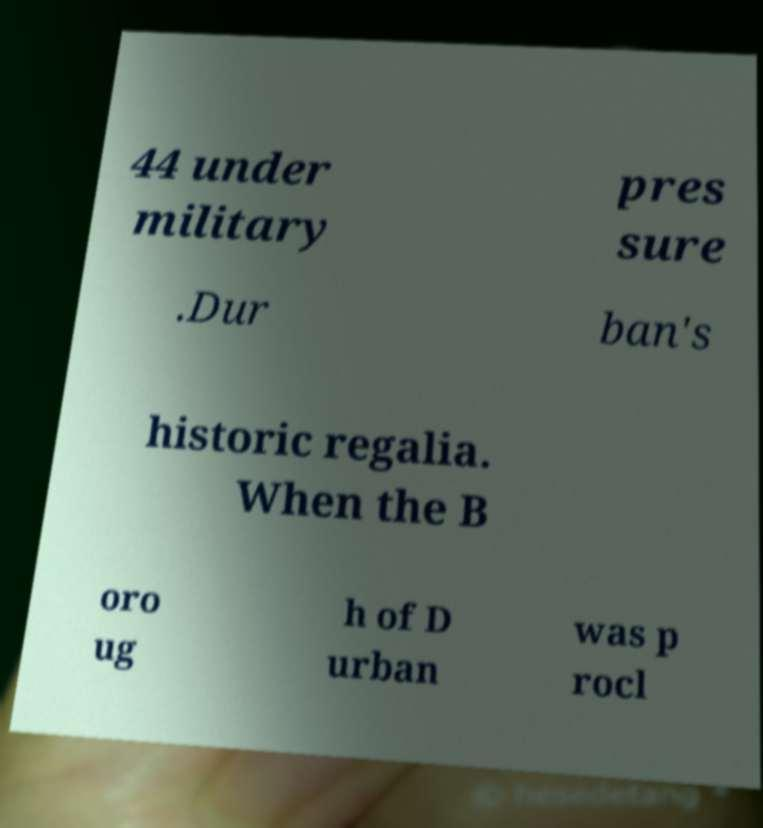Please read and relay the text visible in this image. What does it say? 44 under military pres sure .Dur ban's historic regalia. When the B oro ug h of D urban was p rocl 